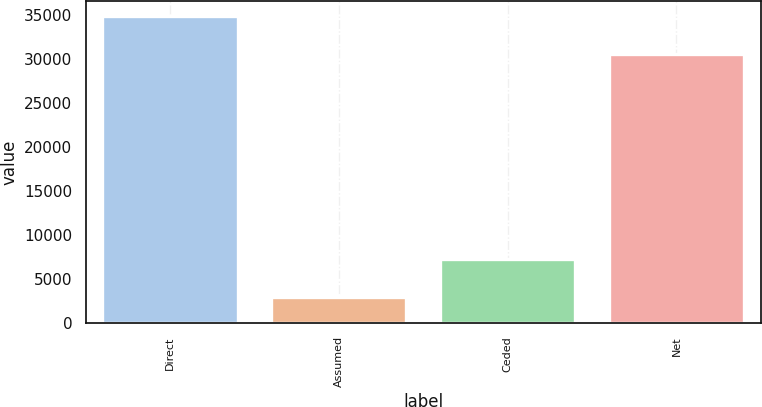<chart> <loc_0><loc_0><loc_500><loc_500><bar_chart><fcel>Direct<fcel>Assumed<fcel>Ceded<fcel>Net<nl><fcel>34869<fcel>2962<fcel>7284<fcel>30547<nl></chart> 